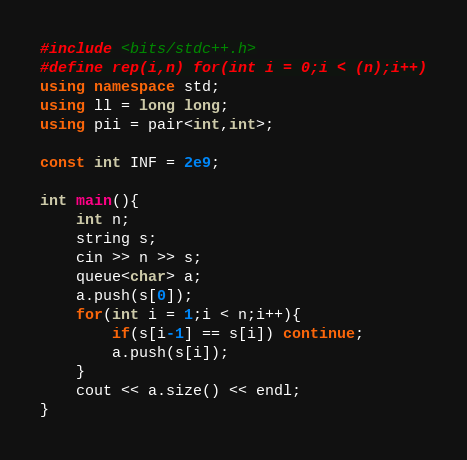<code> <loc_0><loc_0><loc_500><loc_500><_C++_>#include <bits/stdc++.h>
#define rep(i,n) for(int i = 0;i < (n);i++)
using namespace std;
using ll = long long;
using pii = pair<int,int>;

const int INF = 2e9;

int main(){
    int n;
    string s;
    cin >> n >> s;
    queue<char> a;
    a.push(s[0]);
    for(int i = 1;i < n;i++){
        if(s[i-1] == s[i]) continue;
        a.push(s[i]);
    }
    cout << a.size() << endl;
}</code> 